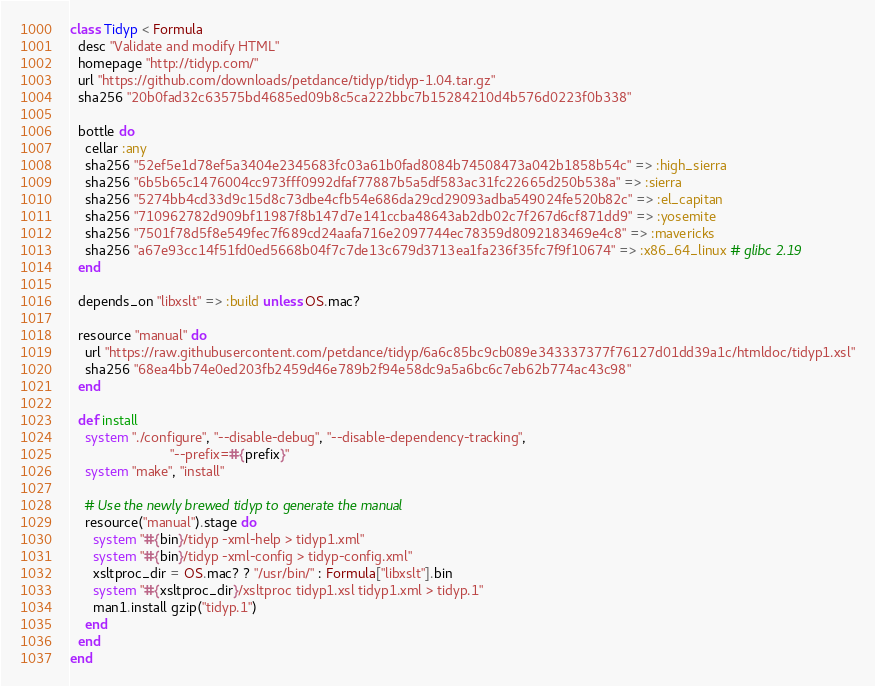Convert code to text. <code><loc_0><loc_0><loc_500><loc_500><_Ruby_>class Tidyp < Formula
  desc "Validate and modify HTML"
  homepage "http://tidyp.com/"
  url "https://github.com/downloads/petdance/tidyp/tidyp-1.04.tar.gz"
  sha256 "20b0fad32c63575bd4685ed09b8c5ca222bbc7b15284210d4b576d0223f0b338"

  bottle do
    cellar :any
    sha256 "52ef5e1d78ef5a3404e2345683fc03a61b0fad8084b74508473a042b1858b54c" => :high_sierra
    sha256 "6b5b65c1476004cc973fff0992dfaf77887b5a5df583ac31fc22665d250b538a" => :sierra
    sha256 "5274bb4cd33d9c15d8c73dbe4cfb54e686da29cd29093adba549024fe520b82c" => :el_capitan
    sha256 "710962782d909bf11987f8b147d7e141ccba48643ab2db02c7f267d6cf871dd9" => :yosemite
    sha256 "7501f78d5f8e549fec7f689cd24aafa716e2097744ec78359d8092183469e4c8" => :mavericks
    sha256 "a67e93cc14f51fd0ed5668b04f7c7de13c679d3713ea1fa236f35fc7f9f10674" => :x86_64_linux # glibc 2.19
  end

  depends_on "libxslt" => :build unless OS.mac?

  resource "manual" do
    url "https://raw.githubusercontent.com/petdance/tidyp/6a6c85bc9cb089e343337377f76127d01dd39a1c/htmldoc/tidyp1.xsl"
    sha256 "68ea4bb74e0ed203fb2459d46e789b2f94e58dc9a5a6bc6c7eb62b774ac43c98"
  end

  def install
    system "./configure", "--disable-debug", "--disable-dependency-tracking",
                          "--prefix=#{prefix}"
    system "make", "install"

    # Use the newly brewed tidyp to generate the manual
    resource("manual").stage do
      system "#{bin}/tidyp -xml-help > tidyp1.xml"
      system "#{bin}/tidyp -xml-config > tidyp-config.xml"
      xsltproc_dir = OS.mac? ? "/usr/bin/" : Formula["libxslt"].bin
      system "#{xsltproc_dir}/xsltproc tidyp1.xsl tidyp1.xml > tidyp.1"
      man1.install gzip("tidyp.1")
    end
  end
end
</code> 